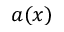<formula> <loc_0><loc_0><loc_500><loc_500>a ( x )</formula> 